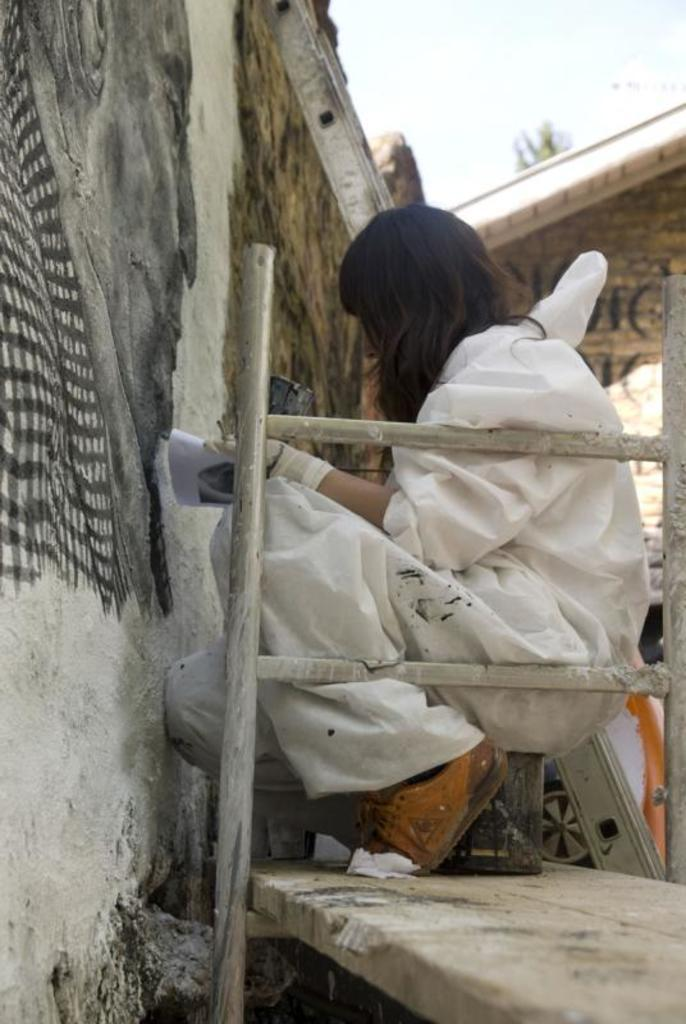What is the person in the image sitting on? The person is sitting on an object in the image. What type of surface is the object resting on? The object is on a wooden surface. What type of structures can be seen in the background of the image? There are houses visible in the image. What type of plant is present in the image? There is a tree in the image. What additional object can be seen in the image? There is a ladder in the image. What part of the natural environment is visible in the image? The sky is visible in the image. What type of cows can be seen grazing in the image? There are no cows present in the image. What is the title of the image? The image does not have a title. 